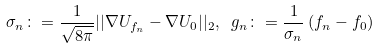<formula> <loc_0><loc_0><loc_500><loc_500>\sigma _ { n } \colon = \frac { 1 } { \sqrt { 8 \pi } } | | \nabla U _ { f _ { n } } - \nabla U _ { 0 } | | _ { 2 } , \ g _ { n } \colon = \frac { 1 } { \sigma _ { n } } \left ( f _ { n } - f _ { 0 } \right )</formula> 